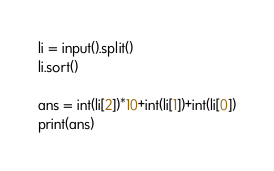<code> <loc_0><loc_0><loc_500><loc_500><_Python_>li = input().split()
li.sort()

ans = int(li[2])*10+int(li[1])+int(li[0])
print(ans)
</code> 